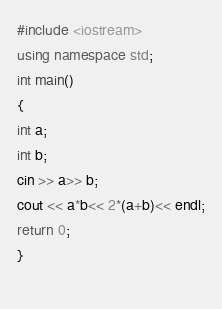Convert code to text. <code><loc_0><loc_0><loc_500><loc_500><_C++_>#include <iostream>
using namespace std;
int main()
{
int a;
int b;
cin >> a>> b;
cout << a*b<< 2*(a+b)<< endl;
return 0;
}
   </code> 